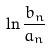Convert formula to latex. <formula><loc_0><loc_0><loc_500><loc_500>\ln \frac { b _ { n } } { a _ { n } }</formula> 